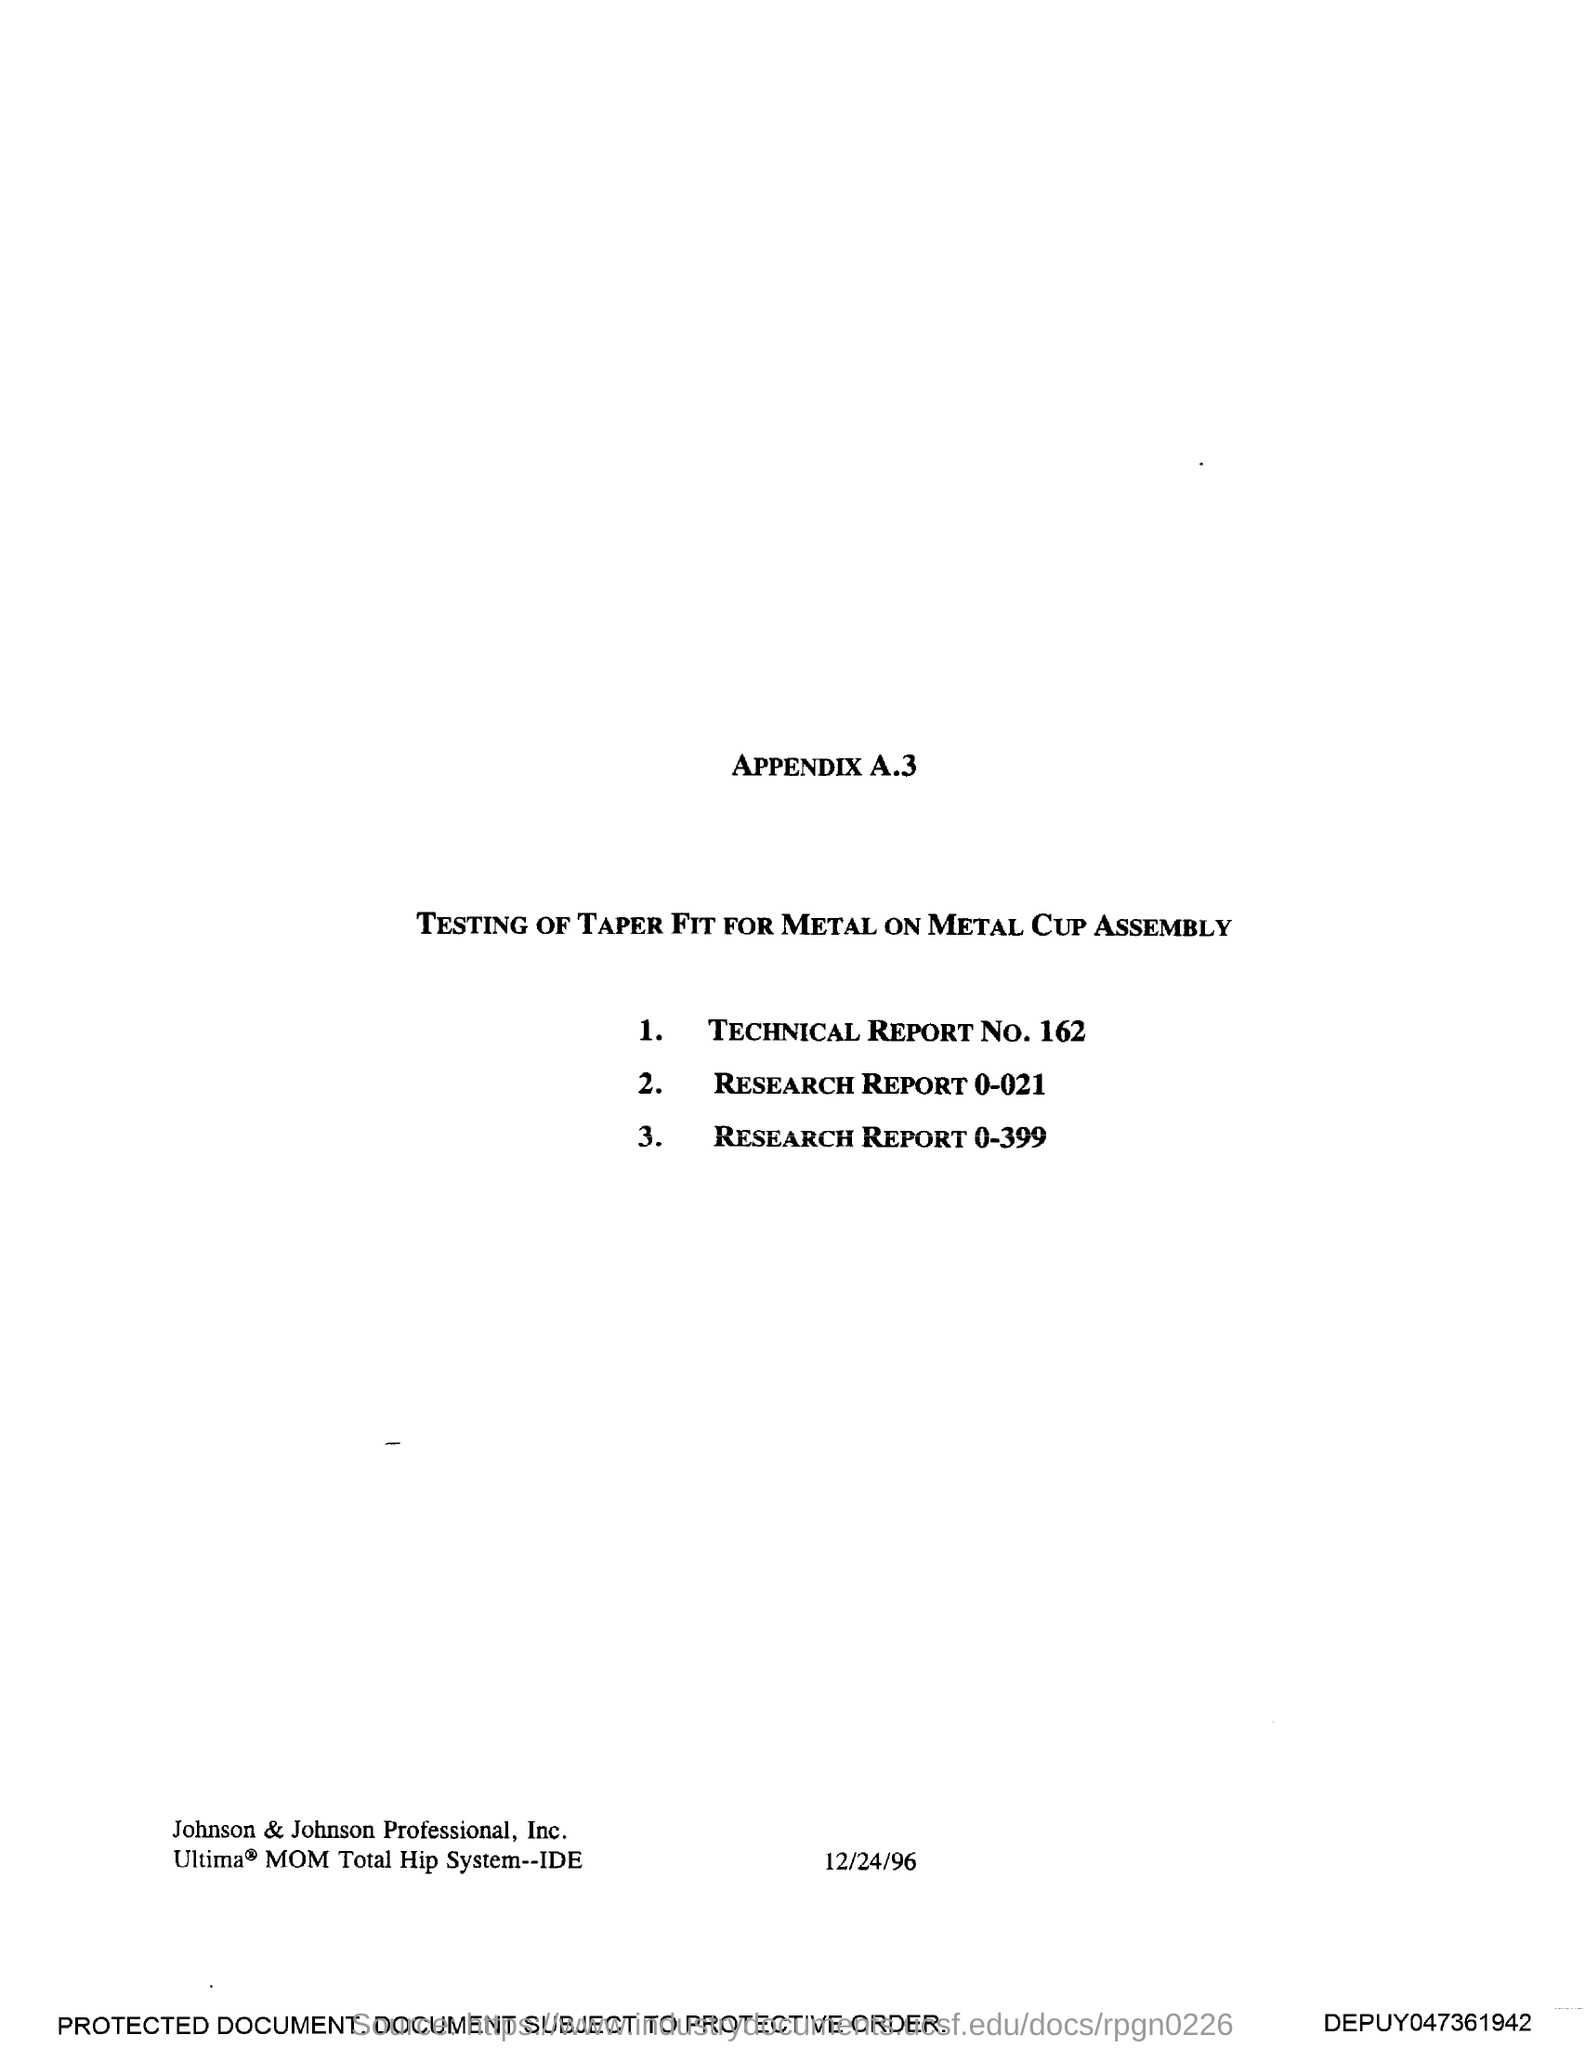Specify some key components in this picture. The date mentioned in this document is December 24, 1996. 